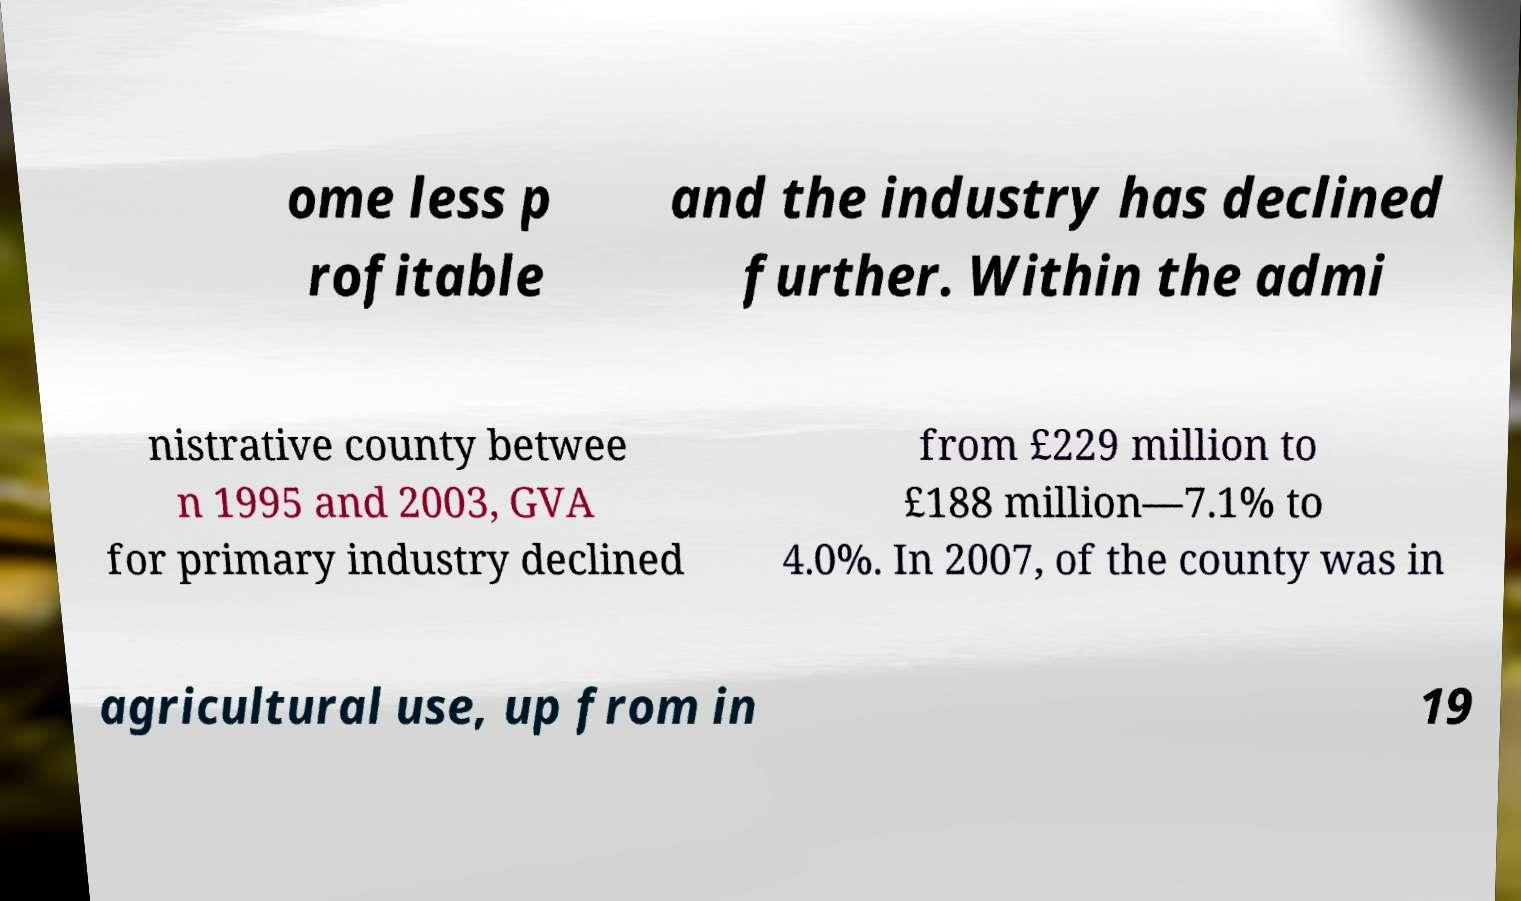Could you assist in decoding the text presented in this image and type it out clearly? ome less p rofitable and the industry has declined further. Within the admi nistrative county betwee n 1995 and 2003, GVA for primary industry declined from £229 million to £188 million—7.1% to 4.0%. In 2007, of the county was in agricultural use, up from in 19 